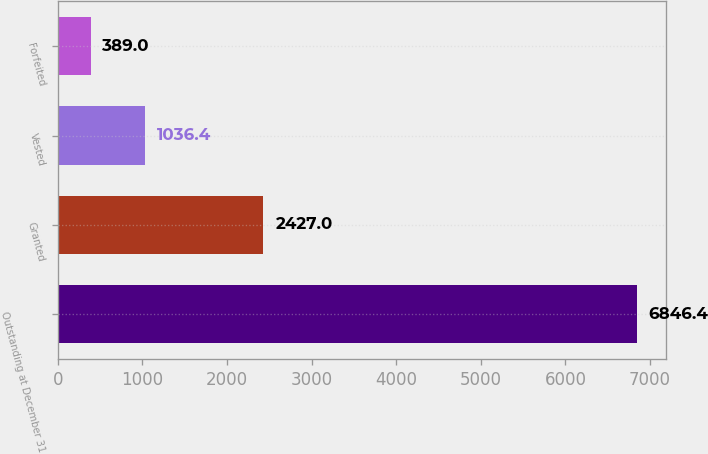Convert chart. <chart><loc_0><loc_0><loc_500><loc_500><bar_chart><fcel>Outstanding at December 31<fcel>Granted<fcel>Vested<fcel>Forfeited<nl><fcel>6846.4<fcel>2427<fcel>1036.4<fcel>389<nl></chart> 